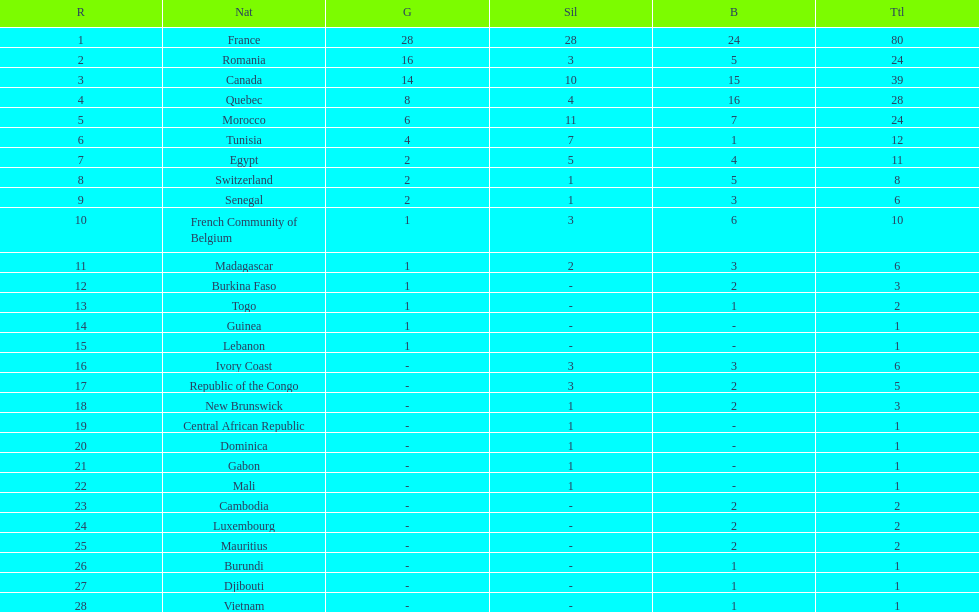What is the distinction between france's and egypt's silver medals? 23. 